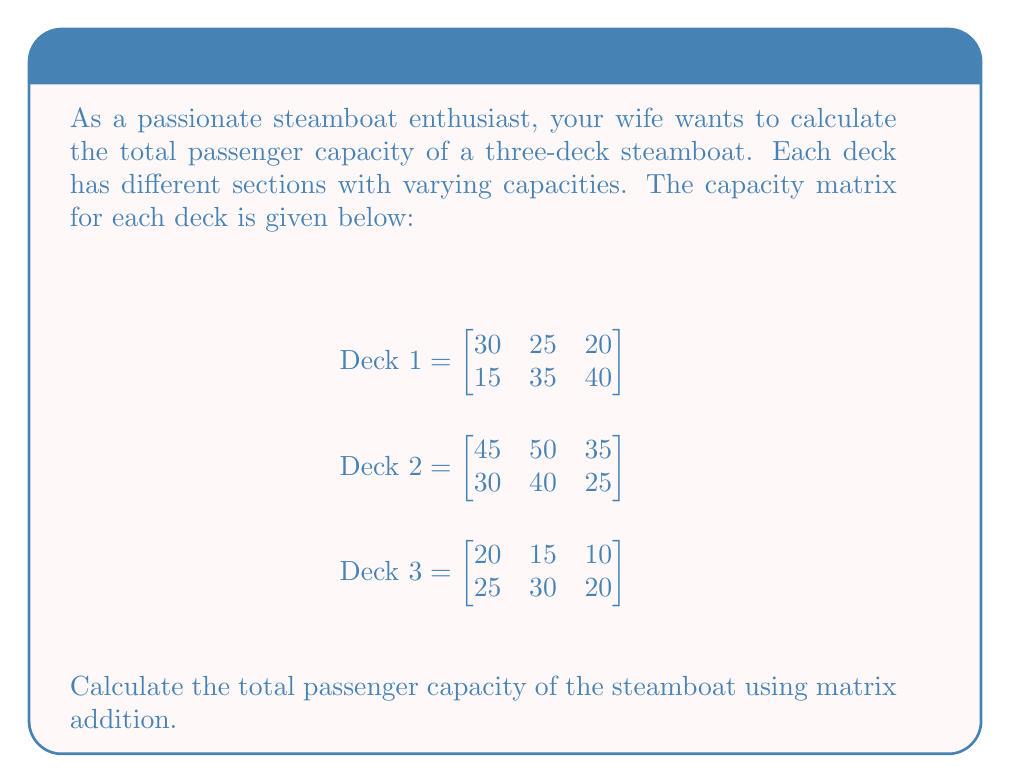Help me with this question. To calculate the total passenger capacity of the steamboat, we need to add the capacity matrices of all three decks. This can be done using matrix addition.

Step 1: Add the matrices element-wise.

$$\begin{aligned}
\text{Total Capacity} &= \text{Deck 1} + \text{Deck 2} + \text{Deck 3} \\[10pt]
&= \begin{bmatrix}
30 & 25 & 20 \\
15 & 35 & 40
\end{bmatrix} + 
\begin{bmatrix}
45 & 50 & 35 \\
30 & 40 & 25
\end{bmatrix} + 
\begin{bmatrix}
20 & 15 & 10 \\
25 & 30 & 20
\end{bmatrix} \\[10pt]
&= \begin{bmatrix}
(30+45+20) & (25+50+15) & (20+35+10) \\
(15+30+25) & (35+40+30) & (40+25+20)
\end{bmatrix} \\[10pt]
&= \begin{bmatrix}
95 & 90 & 65 \\
70 & 105 & 85
\end{bmatrix}
\end{aligned}$$

Step 2: Sum all elements in the resulting matrix to get the total capacity.

Total Capacity = 95 + 90 + 65 + 70 + 105 + 85 = 510

Therefore, the total passenger capacity of the steamboat is 510 passengers.
Answer: 510 passengers 